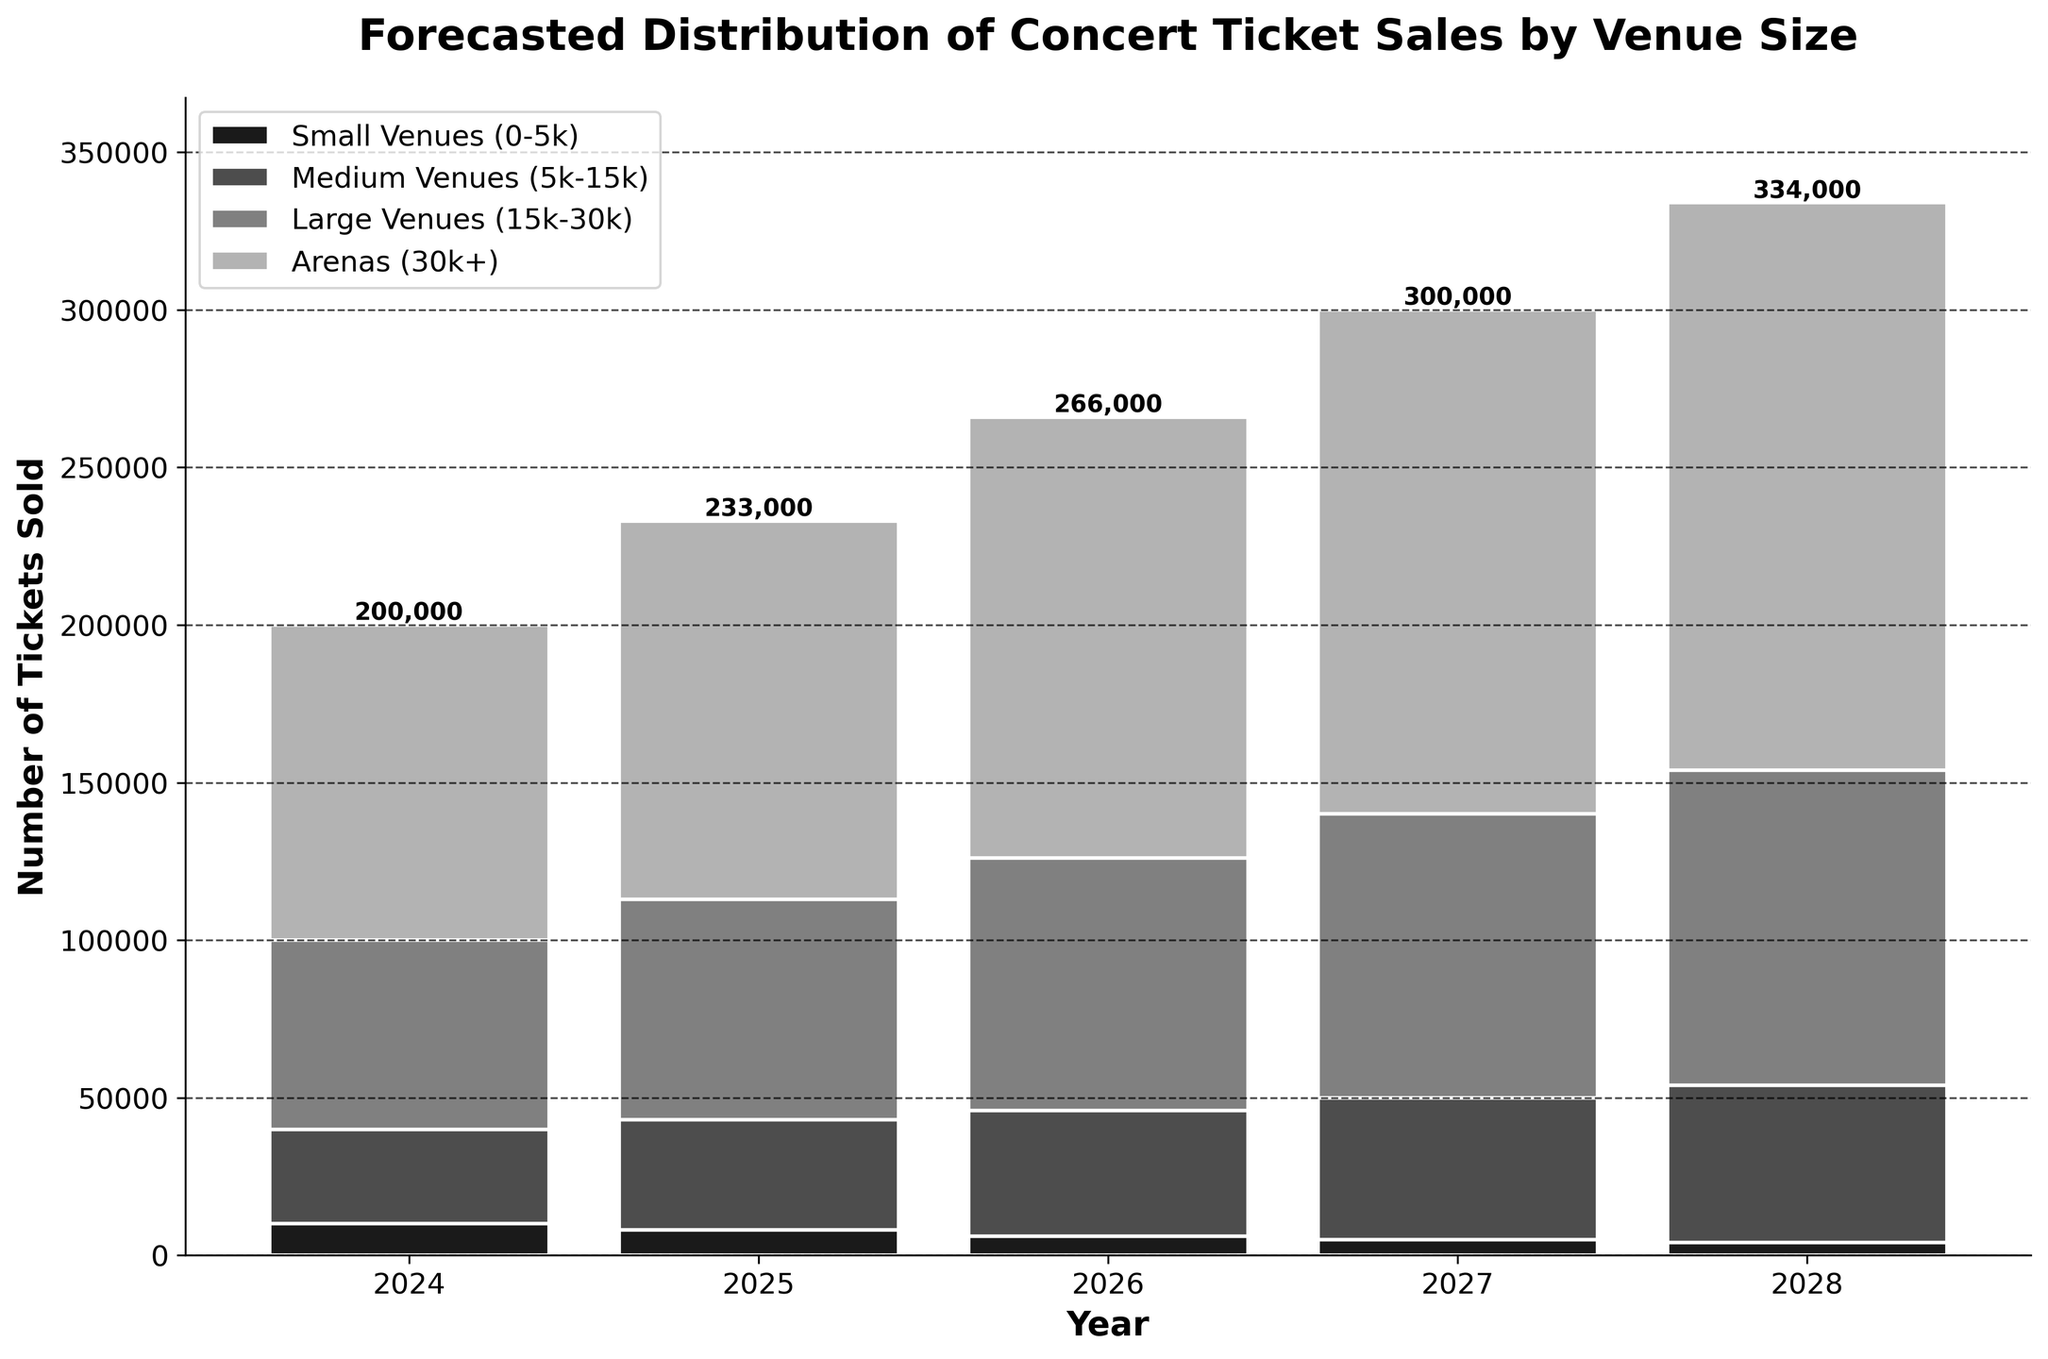What is the title of the chart? The title is located at the top of the chart in bold text, usually indicating what the chart represents.
Answer: Forecasted Distribution of Concert Ticket Sales by Venue Size How many venue sizes are represented in the chart? By looking at the legend on the chart, we can count the different categories.
Answer: Four In which year are the forecasted ticket sales for mediums venues the highest? We identify the highest bar segment among the medium venues for each year and note the corresponding year on the x-axis.
Answer: 2028 What is the trend of ticket sales for small venues from 2024 to 2028? We observe the height of bars for small venues from 2024 to 2028 and describe the overall pattern.
Answer: Decreasing What is the total number of ticket sales forecasted for all venues combined in the year 2026? Add up the number of tickets for all venue sizes in 2026 from the given data.
Answer: 266,000 Which venue size has the smallest increase in ticket sales from 2024 to 2028? Calculate the difference in ticket sales for each venue size from 2024 to 2028, then identify the smallest difference.
Answer: Small Venues (0-5k) Compare the ticket sales for large venues and arenas in 2025. Which one is higher and by how much? Look at the heights of the bars for large venues and arenas in 2025, subtract the sales of large venues from the sales of arenas.
Answer: Arenas, by 50,000 What's the growth rate of ticket sales for arenas from 2024 to 2028? Subtract the 2024 sales from 2028 sales for Arenas, then divide by 2024 sales and multiply by 100 to get the percentage.
Answer: 80% In which year did total forecasted ticket sales see the largest year-over-year increase? Compute the year-over-year difference for total ticket sales and identify the year with the largest increase.
Answer: 2027 What is the overall distribution of ticket sales across different venues in 2024? Observe the relative heights of the bars for each venue size in 2024 and describe the proportion visually.
Answer: Mostly Arenas, followed by Large, Medium, and then Small Venues 